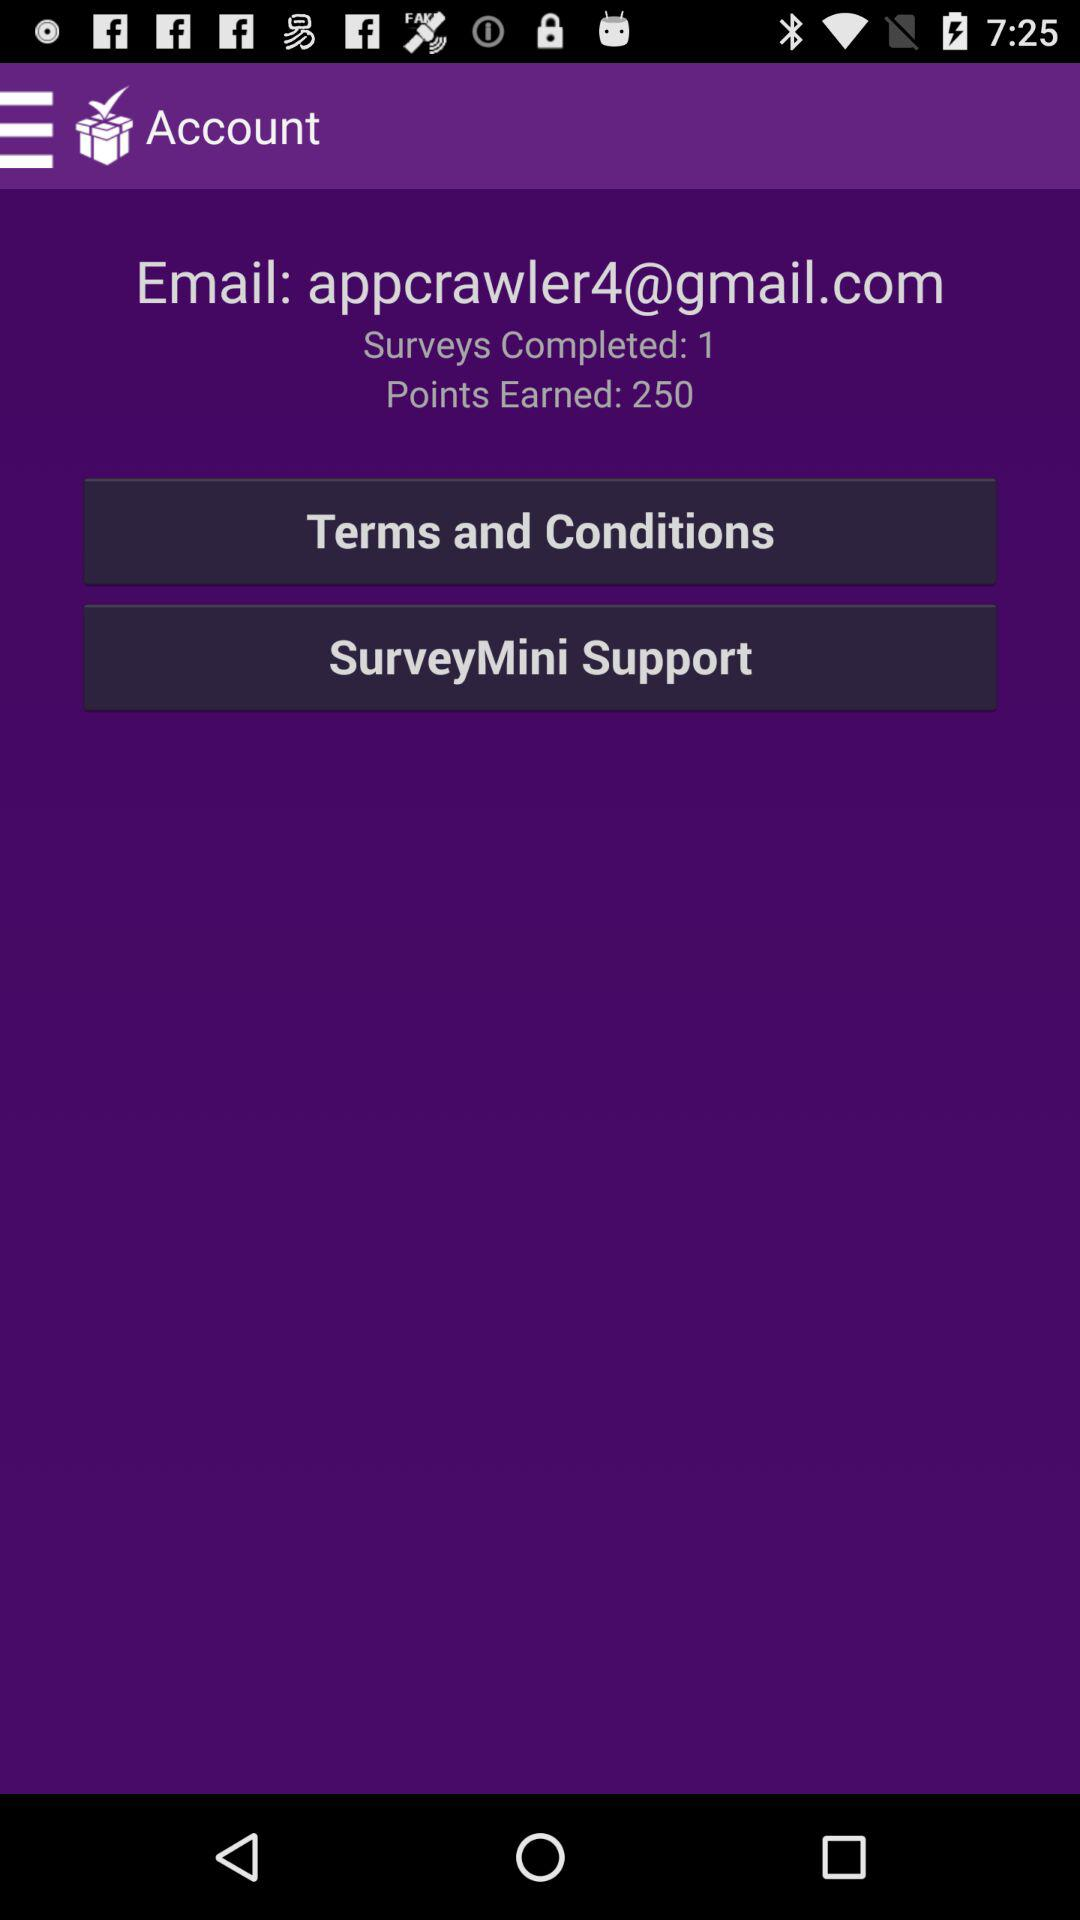What is the number of surveys completed? The number of surveys completed is 1. 